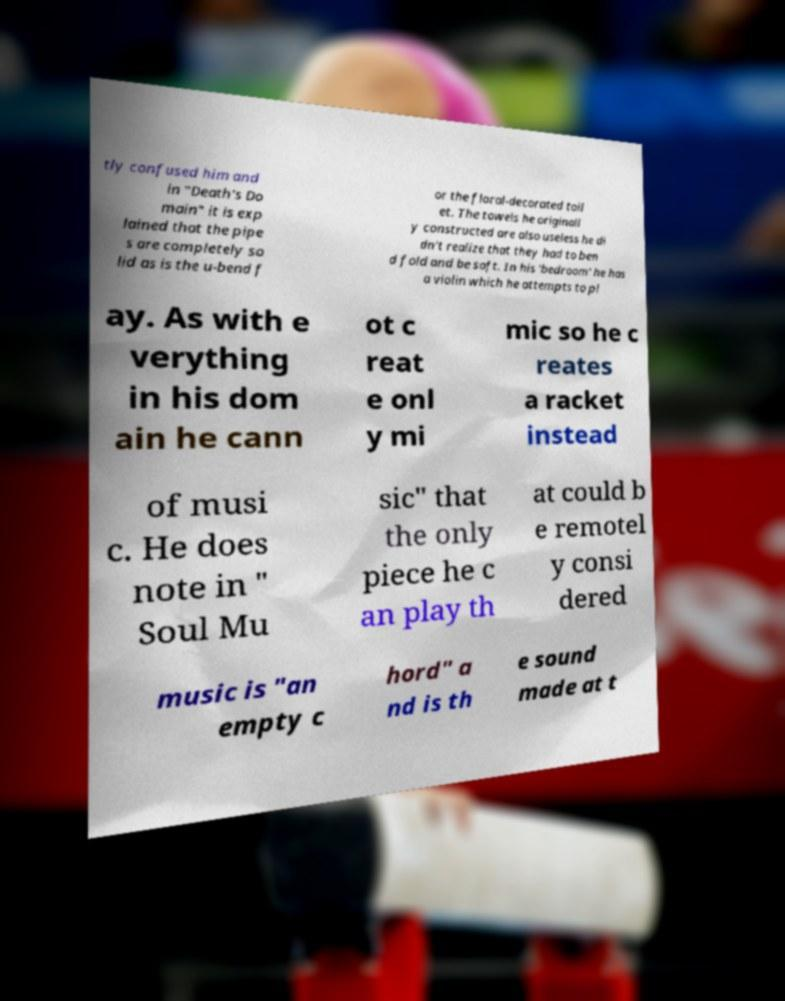Can you accurately transcribe the text from the provided image for me? tly confused him and in "Death's Do main" it is exp lained that the pipe s are completely so lid as is the u-bend f or the floral-decorated toil et. The towels he originall y constructed are also useless he di dn't realize that they had to ben d fold and be soft. In his 'bedroom' he has a violin which he attempts to pl ay. As with e verything in his dom ain he cann ot c reat e onl y mi mic so he c reates a racket instead of musi c. He does note in " Soul Mu sic" that the only piece he c an play th at could b e remotel y consi dered music is "an empty c hord" a nd is th e sound made at t 